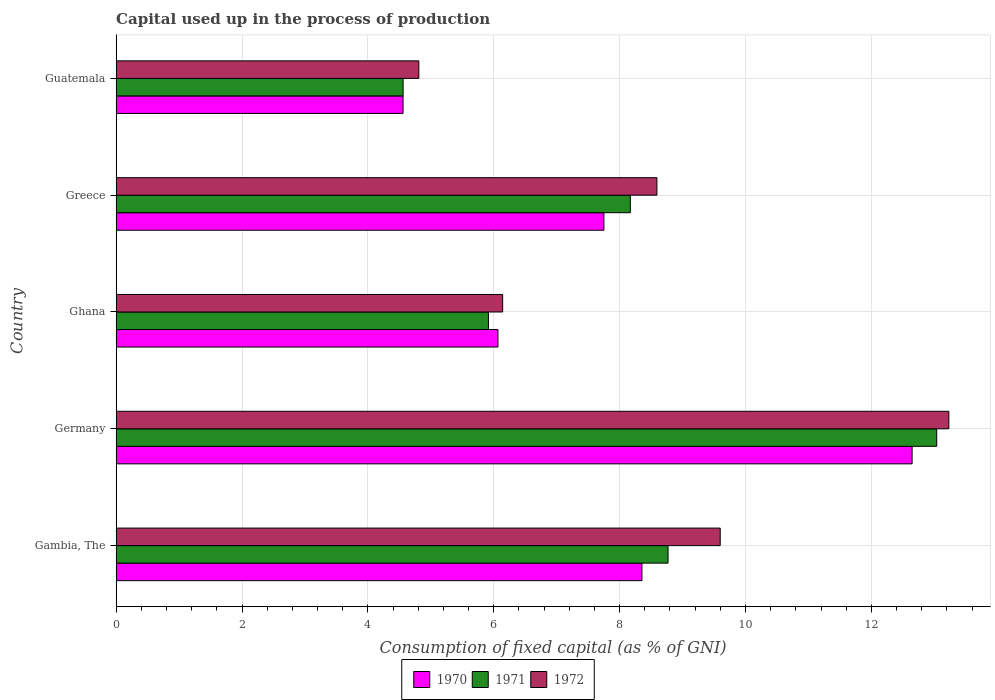Are the number of bars per tick equal to the number of legend labels?
Your answer should be compact. Yes. How many bars are there on the 3rd tick from the top?
Your answer should be very brief. 3. How many bars are there on the 5th tick from the bottom?
Your response must be concise. 3. What is the label of the 3rd group of bars from the top?
Provide a succinct answer. Ghana. What is the capital used up in the process of production in 1972 in Germany?
Ensure brevity in your answer.  13.23. Across all countries, what is the maximum capital used up in the process of production in 1972?
Ensure brevity in your answer.  13.23. Across all countries, what is the minimum capital used up in the process of production in 1970?
Your answer should be very brief. 4.56. In which country was the capital used up in the process of production in 1971 minimum?
Your response must be concise. Guatemala. What is the total capital used up in the process of production in 1972 in the graph?
Offer a terse response. 42.37. What is the difference between the capital used up in the process of production in 1972 in Germany and that in Guatemala?
Provide a short and direct response. 8.42. What is the difference between the capital used up in the process of production in 1970 in Greece and the capital used up in the process of production in 1972 in Ghana?
Keep it short and to the point. 1.61. What is the average capital used up in the process of production in 1970 per country?
Make the answer very short. 7.88. What is the difference between the capital used up in the process of production in 1971 and capital used up in the process of production in 1970 in Greece?
Provide a short and direct response. 0.42. What is the ratio of the capital used up in the process of production in 1971 in Gambia, The to that in Greece?
Your answer should be compact. 1.07. What is the difference between the highest and the second highest capital used up in the process of production in 1972?
Provide a short and direct response. 3.63. What is the difference between the highest and the lowest capital used up in the process of production in 1972?
Provide a short and direct response. 8.42. In how many countries, is the capital used up in the process of production in 1971 greater than the average capital used up in the process of production in 1971 taken over all countries?
Give a very brief answer. 3. What does the 1st bar from the bottom in Germany represents?
Your response must be concise. 1970. How many countries are there in the graph?
Your answer should be compact. 5. Are the values on the major ticks of X-axis written in scientific E-notation?
Offer a very short reply. No. Does the graph contain grids?
Provide a succinct answer. Yes. Where does the legend appear in the graph?
Your answer should be very brief. Bottom center. How many legend labels are there?
Offer a terse response. 3. How are the legend labels stacked?
Give a very brief answer. Horizontal. What is the title of the graph?
Your response must be concise. Capital used up in the process of production. Does "2015" appear as one of the legend labels in the graph?
Make the answer very short. No. What is the label or title of the X-axis?
Your answer should be very brief. Consumption of fixed capital (as % of GNI). What is the Consumption of fixed capital (as % of GNI) of 1970 in Gambia, The?
Your answer should be compact. 8.35. What is the Consumption of fixed capital (as % of GNI) of 1971 in Gambia, The?
Keep it short and to the point. 8.77. What is the Consumption of fixed capital (as % of GNI) in 1972 in Gambia, The?
Keep it short and to the point. 9.6. What is the Consumption of fixed capital (as % of GNI) in 1970 in Germany?
Ensure brevity in your answer.  12.65. What is the Consumption of fixed capital (as % of GNI) of 1971 in Germany?
Keep it short and to the point. 13.04. What is the Consumption of fixed capital (as % of GNI) of 1972 in Germany?
Make the answer very short. 13.23. What is the Consumption of fixed capital (as % of GNI) of 1970 in Ghana?
Provide a short and direct response. 6.07. What is the Consumption of fixed capital (as % of GNI) of 1971 in Ghana?
Give a very brief answer. 5.92. What is the Consumption of fixed capital (as % of GNI) in 1972 in Ghana?
Keep it short and to the point. 6.14. What is the Consumption of fixed capital (as % of GNI) of 1970 in Greece?
Ensure brevity in your answer.  7.75. What is the Consumption of fixed capital (as % of GNI) in 1971 in Greece?
Keep it short and to the point. 8.17. What is the Consumption of fixed capital (as % of GNI) of 1972 in Greece?
Your response must be concise. 8.59. What is the Consumption of fixed capital (as % of GNI) of 1970 in Guatemala?
Ensure brevity in your answer.  4.56. What is the Consumption of fixed capital (as % of GNI) in 1971 in Guatemala?
Offer a terse response. 4.56. What is the Consumption of fixed capital (as % of GNI) of 1972 in Guatemala?
Make the answer very short. 4.81. Across all countries, what is the maximum Consumption of fixed capital (as % of GNI) in 1970?
Give a very brief answer. 12.65. Across all countries, what is the maximum Consumption of fixed capital (as % of GNI) of 1971?
Provide a succinct answer. 13.04. Across all countries, what is the maximum Consumption of fixed capital (as % of GNI) in 1972?
Your answer should be compact. 13.23. Across all countries, what is the minimum Consumption of fixed capital (as % of GNI) in 1970?
Your response must be concise. 4.56. Across all countries, what is the minimum Consumption of fixed capital (as % of GNI) of 1971?
Offer a very short reply. 4.56. Across all countries, what is the minimum Consumption of fixed capital (as % of GNI) of 1972?
Provide a short and direct response. 4.81. What is the total Consumption of fixed capital (as % of GNI) in 1970 in the graph?
Give a very brief answer. 39.38. What is the total Consumption of fixed capital (as % of GNI) in 1971 in the graph?
Keep it short and to the point. 40.45. What is the total Consumption of fixed capital (as % of GNI) in 1972 in the graph?
Make the answer very short. 42.37. What is the difference between the Consumption of fixed capital (as % of GNI) of 1970 in Gambia, The and that in Germany?
Your answer should be compact. -4.29. What is the difference between the Consumption of fixed capital (as % of GNI) in 1971 in Gambia, The and that in Germany?
Offer a terse response. -4.27. What is the difference between the Consumption of fixed capital (as % of GNI) in 1972 in Gambia, The and that in Germany?
Your answer should be very brief. -3.63. What is the difference between the Consumption of fixed capital (as % of GNI) of 1970 in Gambia, The and that in Ghana?
Provide a succinct answer. 2.29. What is the difference between the Consumption of fixed capital (as % of GNI) in 1971 in Gambia, The and that in Ghana?
Your answer should be compact. 2.85. What is the difference between the Consumption of fixed capital (as % of GNI) of 1972 in Gambia, The and that in Ghana?
Offer a very short reply. 3.46. What is the difference between the Consumption of fixed capital (as % of GNI) in 1970 in Gambia, The and that in Greece?
Your answer should be very brief. 0.6. What is the difference between the Consumption of fixed capital (as % of GNI) of 1971 in Gambia, The and that in Greece?
Give a very brief answer. 0.6. What is the difference between the Consumption of fixed capital (as % of GNI) of 1970 in Gambia, The and that in Guatemala?
Your response must be concise. 3.8. What is the difference between the Consumption of fixed capital (as % of GNI) in 1971 in Gambia, The and that in Guatemala?
Your answer should be very brief. 4.21. What is the difference between the Consumption of fixed capital (as % of GNI) of 1972 in Gambia, The and that in Guatemala?
Offer a very short reply. 4.79. What is the difference between the Consumption of fixed capital (as % of GNI) in 1970 in Germany and that in Ghana?
Make the answer very short. 6.58. What is the difference between the Consumption of fixed capital (as % of GNI) of 1971 in Germany and that in Ghana?
Your response must be concise. 7.12. What is the difference between the Consumption of fixed capital (as % of GNI) of 1972 in Germany and that in Ghana?
Offer a terse response. 7.09. What is the difference between the Consumption of fixed capital (as % of GNI) of 1970 in Germany and that in Greece?
Ensure brevity in your answer.  4.9. What is the difference between the Consumption of fixed capital (as % of GNI) of 1971 in Germany and that in Greece?
Your answer should be very brief. 4.87. What is the difference between the Consumption of fixed capital (as % of GNI) of 1972 in Germany and that in Greece?
Give a very brief answer. 4.64. What is the difference between the Consumption of fixed capital (as % of GNI) of 1970 in Germany and that in Guatemala?
Give a very brief answer. 8.09. What is the difference between the Consumption of fixed capital (as % of GNI) in 1971 in Germany and that in Guatemala?
Provide a short and direct response. 8.48. What is the difference between the Consumption of fixed capital (as % of GNI) in 1972 in Germany and that in Guatemala?
Provide a succinct answer. 8.42. What is the difference between the Consumption of fixed capital (as % of GNI) in 1970 in Ghana and that in Greece?
Your answer should be compact. -1.68. What is the difference between the Consumption of fixed capital (as % of GNI) in 1971 in Ghana and that in Greece?
Give a very brief answer. -2.25. What is the difference between the Consumption of fixed capital (as % of GNI) of 1972 in Ghana and that in Greece?
Your response must be concise. -2.45. What is the difference between the Consumption of fixed capital (as % of GNI) in 1970 in Ghana and that in Guatemala?
Offer a terse response. 1.51. What is the difference between the Consumption of fixed capital (as % of GNI) in 1971 in Ghana and that in Guatemala?
Provide a short and direct response. 1.36. What is the difference between the Consumption of fixed capital (as % of GNI) in 1972 in Ghana and that in Guatemala?
Your answer should be compact. 1.33. What is the difference between the Consumption of fixed capital (as % of GNI) in 1970 in Greece and that in Guatemala?
Ensure brevity in your answer.  3.19. What is the difference between the Consumption of fixed capital (as % of GNI) in 1971 in Greece and that in Guatemala?
Provide a succinct answer. 3.61. What is the difference between the Consumption of fixed capital (as % of GNI) of 1972 in Greece and that in Guatemala?
Give a very brief answer. 3.78. What is the difference between the Consumption of fixed capital (as % of GNI) in 1970 in Gambia, The and the Consumption of fixed capital (as % of GNI) in 1971 in Germany?
Your response must be concise. -4.68. What is the difference between the Consumption of fixed capital (as % of GNI) in 1970 in Gambia, The and the Consumption of fixed capital (as % of GNI) in 1972 in Germany?
Give a very brief answer. -4.88. What is the difference between the Consumption of fixed capital (as % of GNI) of 1971 in Gambia, The and the Consumption of fixed capital (as % of GNI) of 1972 in Germany?
Your response must be concise. -4.46. What is the difference between the Consumption of fixed capital (as % of GNI) in 1970 in Gambia, The and the Consumption of fixed capital (as % of GNI) in 1971 in Ghana?
Ensure brevity in your answer.  2.44. What is the difference between the Consumption of fixed capital (as % of GNI) of 1970 in Gambia, The and the Consumption of fixed capital (as % of GNI) of 1972 in Ghana?
Make the answer very short. 2.21. What is the difference between the Consumption of fixed capital (as % of GNI) in 1971 in Gambia, The and the Consumption of fixed capital (as % of GNI) in 1972 in Ghana?
Your answer should be compact. 2.63. What is the difference between the Consumption of fixed capital (as % of GNI) of 1970 in Gambia, The and the Consumption of fixed capital (as % of GNI) of 1971 in Greece?
Make the answer very short. 0.18. What is the difference between the Consumption of fixed capital (as % of GNI) of 1970 in Gambia, The and the Consumption of fixed capital (as % of GNI) of 1972 in Greece?
Keep it short and to the point. -0.24. What is the difference between the Consumption of fixed capital (as % of GNI) in 1971 in Gambia, The and the Consumption of fixed capital (as % of GNI) in 1972 in Greece?
Your response must be concise. 0.18. What is the difference between the Consumption of fixed capital (as % of GNI) of 1970 in Gambia, The and the Consumption of fixed capital (as % of GNI) of 1971 in Guatemala?
Offer a terse response. 3.79. What is the difference between the Consumption of fixed capital (as % of GNI) of 1970 in Gambia, The and the Consumption of fixed capital (as % of GNI) of 1972 in Guatemala?
Offer a very short reply. 3.54. What is the difference between the Consumption of fixed capital (as % of GNI) of 1971 in Gambia, The and the Consumption of fixed capital (as % of GNI) of 1972 in Guatemala?
Give a very brief answer. 3.96. What is the difference between the Consumption of fixed capital (as % of GNI) in 1970 in Germany and the Consumption of fixed capital (as % of GNI) in 1971 in Ghana?
Give a very brief answer. 6.73. What is the difference between the Consumption of fixed capital (as % of GNI) of 1970 in Germany and the Consumption of fixed capital (as % of GNI) of 1972 in Ghana?
Give a very brief answer. 6.51. What is the difference between the Consumption of fixed capital (as % of GNI) in 1971 in Germany and the Consumption of fixed capital (as % of GNI) in 1972 in Ghana?
Provide a short and direct response. 6.9. What is the difference between the Consumption of fixed capital (as % of GNI) of 1970 in Germany and the Consumption of fixed capital (as % of GNI) of 1971 in Greece?
Your answer should be compact. 4.48. What is the difference between the Consumption of fixed capital (as % of GNI) of 1970 in Germany and the Consumption of fixed capital (as % of GNI) of 1972 in Greece?
Your answer should be compact. 4.05. What is the difference between the Consumption of fixed capital (as % of GNI) in 1971 in Germany and the Consumption of fixed capital (as % of GNI) in 1972 in Greece?
Keep it short and to the point. 4.45. What is the difference between the Consumption of fixed capital (as % of GNI) in 1970 in Germany and the Consumption of fixed capital (as % of GNI) in 1971 in Guatemala?
Keep it short and to the point. 8.09. What is the difference between the Consumption of fixed capital (as % of GNI) in 1970 in Germany and the Consumption of fixed capital (as % of GNI) in 1972 in Guatemala?
Keep it short and to the point. 7.84. What is the difference between the Consumption of fixed capital (as % of GNI) of 1971 in Germany and the Consumption of fixed capital (as % of GNI) of 1972 in Guatemala?
Your answer should be very brief. 8.23. What is the difference between the Consumption of fixed capital (as % of GNI) of 1970 in Ghana and the Consumption of fixed capital (as % of GNI) of 1971 in Greece?
Offer a very short reply. -2.1. What is the difference between the Consumption of fixed capital (as % of GNI) of 1970 in Ghana and the Consumption of fixed capital (as % of GNI) of 1972 in Greece?
Offer a very short reply. -2.53. What is the difference between the Consumption of fixed capital (as % of GNI) in 1971 in Ghana and the Consumption of fixed capital (as % of GNI) in 1972 in Greece?
Offer a very short reply. -2.68. What is the difference between the Consumption of fixed capital (as % of GNI) of 1970 in Ghana and the Consumption of fixed capital (as % of GNI) of 1971 in Guatemala?
Offer a very short reply. 1.51. What is the difference between the Consumption of fixed capital (as % of GNI) in 1970 in Ghana and the Consumption of fixed capital (as % of GNI) in 1972 in Guatemala?
Provide a short and direct response. 1.26. What is the difference between the Consumption of fixed capital (as % of GNI) in 1971 in Ghana and the Consumption of fixed capital (as % of GNI) in 1972 in Guatemala?
Your answer should be very brief. 1.11. What is the difference between the Consumption of fixed capital (as % of GNI) in 1970 in Greece and the Consumption of fixed capital (as % of GNI) in 1971 in Guatemala?
Make the answer very short. 3.19. What is the difference between the Consumption of fixed capital (as % of GNI) in 1970 in Greece and the Consumption of fixed capital (as % of GNI) in 1972 in Guatemala?
Give a very brief answer. 2.94. What is the difference between the Consumption of fixed capital (as % of GNI) of 1971 in Greece and the Consumption of fixed capital (as % of GNI) of 1972 in Guatemala?
Provide a succinct answer. 3.36. What is the average Consumption of fixed capital (as % of GNI) of 1970 per country?
Your answer should be very brief. 7.88. What is the average Consumption of fixed capital (as % of GNI) of 1971 per country?
Give a very brief answer. 8.09. What is the average Consumption of fixed capital (as % of GNI) in 1972 per country?
Give a very brief answer. 8.47. What is the difference between the Consumption of fixed capital (as % of GNI) in 1970 and Consumption of fixed capital (as % of GNI) in 1971 in Gambia, The?
Your response must be concise. -0.41. What is the difference between the Consumption of fixed capital (as % of GNI) of 1970 and Consumption of fixed capital (as % of GNI) of 1972 in Gambia, The?
Offer a terse response. -1.24. What is the difference between the Consumption of fixed capital (as % of GNI) in 1971 and Consumption of fixed capital (as % of GNI) in 1972 in Gambia, The?
Offer a terse response. -0.83. What is the difference between the Consumption of fixed capital (as % of GNI) in 1970 and Consumption of fixed capital (as % of GNI) in 1971 in Germany?
Keep it short and to the point. -0.39. What is the difference between the Consumption of fixed capital (as % of GNI) in 1970 and Consumption of fixed capital (as % of GNI) in 1972 in Germany?
Your answer should be very brief. -0.58. What is the difference between the Consumption of fixed capital (as % of GNI) of 1971 and Consumption of fixed capital (as % of GNI) of 1972 in Germany?
Offer a very short reply. -0.19. What is the difference between the Consumption of fixed capital (as % of GNI) of 1970 and Consumption of fixed capital (as % of GNI) of 1971 in Ghana?
Provide a succinct answer. 0.15. What is the difference between the Consumption of fixed capital (as % of GNI) of 1970 and Consumption of fixed capital (as % of GNI) of 1972 in Ghana?
Ensure brevity in your answer.  -0.07. What is the difference between the Consumption of fixed capital (as % of GNI) of 1971 and Consumption of fixed capital (as % of GNI) of 1972 in Ghana?
Your answer should be compact. -0.23. What is the difference between the Consumption of fixed capital (as % of GNI) in 1970 and Consumption of fixed capital (as % of GNI) in 1971 in Greece?
Ensure brevity in your answer.  -0.42. What is the difference between the Consumption of fixed capital (as % of GNI) of 1970 and Consumption of fixed capital (as % of GNI) of 1972 in Greece?
Keep it short and to the point. -0.84. What is the difference between the Consumption of fixed capital (as % of GNI) in 1971 and Consumption of fixed capital (as % of GNI) in 1972 in Greece?
Your response must be concise. -0.42. What is the difference between the Consumption of fixed capital (as % of GNI) of 1970 and Consumption of fixed capital (as % of GNI) of 1971 in Guatemala?
Make the answer very short. -0. What is the difference between the Consumption of fixed capital (as % of GNI) in 1970 and Consumption of fixed capital (as % of GNI) in 1972 in Guatemala?
Provide a short and direct response. -0.25. What is the difference between the Consumption of fixed capital (as % of GNI) in 1971 and Consumption of fixed capital (as % of GNI) in 1972 in Guatemala?
Give a very brief answer. -0.25. What is the ratio of the Consumption of fixed capital (as % of GNI) of 1970 in Gambia, The to that in Germany?
Make the answer very short. 0.66. What is the ratio of the Consumption of fixed capital (as % of GNI) of 1971 in Gambia, The to that in Germany?
Keep it short and to the point. 0.67. What is the ratio of the Consumption of fixed capital (as % of GNI) in 1972 in Gambia, The to that in Germany?
Your response must be concise. 0.73. What is the ratio of the Consumption of fixed capital (as % of GNI) in 1970 in Gambia, The to that in Ghana?
Your response must be concise. 1.38. What is the ratio of the Consumption of fixed capital (as % of GNI) in 1971 in Gambia, The to that in Ghana?
Offer a terse response. 1.48. What is the ratio of the Consumption of fixed capital (as % of GNI) of 1972 in Gambia, The to that in Ghana?
Make the answer very short. 1.56. What is the ratio of the Consumption of fixed capital (as % of GNI) in 1970 in Gambia, The to that in Greece?
Offer a terse response. 1.08. What is the ratio of the Consumption of fixed capital (as % of GNI) of 1971 in Gambia, The to that in Greece?
Provide a succinct answer. 1.07. What is the ratio of the Consumption of fixed capital (as % of GNI) in 1972 in Gambia, The to that in Greece?
Give a very brief answer. 1.12. What is the ratio of the Consumption of fixed capital (as % of GNI) of 1970 in Gambia, The to that in Guatemala?
Provide a short and direct response. 1.83. What is the ratio of the Consumption of fixed capital (as % of GNI) of 1971 in Gambia, The to that in Guatemala?
Keep it short and to the point. 1.92. What is the ratio of the Consumption of fixed capital (as % of GNI) in 1972 in Gambia, The to that in Guatemala?
Your answer should be compact. 2. What is the ratio of the Consumption of fixed capital (as % of GNI) in 1970 in Germany to that in Ghana?
Offer a very short reply. 2.08. What is the ratio of the Consumption of fixed capital (as % of GNI) in 1971 in Germany to that in Ghana?
Give a very brief answer. 2.2. What is the ratio of the Consumption of fixed capital (as % of GNI) of 1972 in Germany to that in Ghana?
Give a very brief answer. 2.15. What is the ratio of the Consumption of fixed capital (as % of GNI) in 1970 in Germany to that in Greece?
Ensure brevity in your answer.  1.63. What is the ratio of the Consumption of fixed capital (as % of GNI) of 1971 in Germany to that in Greece?
Make the answer very short. 1.6. What is the ratio of the Consumption of fixed capital (as % of GNI) in 1972 in Germany to that in Greece?
Offer a very short reply. 1.54. What is the ratio of the Consumption of fixed capital (as % of GNI) of 1970 in Germany to that in Guatemala?
Your answer should be compact. 2.77. What is the ratio of the Consumption of fixed capital (as % of GNI) of 1971 in Germany to that in Guatemala?
Give a very brief answer. 2.86. What is the ratio of the Consumption of fixed capital (as % of GNI) in 1972 in Germany to that in Guatemala?
Keep it short and to the point. 2.75. What is the ratio of the Consumption of fixed capital (as % of GNI) in 1970 in Ghana to that in Greece?
Give a very brief answer. 0.78. What is the ratio of the Consumption of fixed capital (as % of GNI) in 1971 in Ghana to that in Greece?
Keep it short and to the point. 0.72. What is the ratio of the Consumption of fixed capital (as % of GNI) in 1972 in Ghana to that in Greece?
Give a very brief answer. 0.71. What is the ratio of the Consumption of fixed capital (as % of GNI) of 1970 in Ghana to that in Guatemala?
Offer a very short reply. 1.33. What is the ratio of the Consumption of fixed capital (as % of GNI) of 1971 in Ghana to that in Guatemala?
Give a very brief answer. 1.3. What is the ratio of the Consumption of fixed capital (as % of GNI) of 1972 in Ghana to that in Guatemala?
Your answer should be compact. 1.28. What is the ratio of the Consumption of fixed capital (as % of GNI) of 1970 in Greece to that in Guatemala?
Provide a short and direct response. 1.7. What is the ratio of the Consumption of fixed capital (as % of GNI) of 1971 in Greece to that in Guatemala?
Ensure brevity in your answer.  1.79. What is the ratio of the Consumption of fixed capital (as % of GNI) in 1972 in Greece to that in Guatemala?
Keep it short and to the point. 1.79. What is the difference between the highest and the second highest Consumption of fixed capital (as % of GNI) in 1970?
Keep it short and to the point. 4.29. What is the difference between the highest and the second highest Consumption of fixed capital (as % of GNI) of 1971?
Your response must be concise. 4.27. What is the difference between the highest and the second highest Consumption of fixed capital (as % of GNI) of 1972?
Offer a very short reply. 3.63. What is the difference between the highest and the lowest Consumption of fixed capital (as % of GNI) of 1970?
Ensure brevity in your answer.  8.09. What is the difference between the highest and the lowest Consumption of fixed capital (as % of GNI) of 1971?
Your answer should be very brief. 8.48. What is the difference between the highest and the lowest Consumption of fixed capital (as % of GNI) in 1972?
Your answer should be compact. 8.42. 